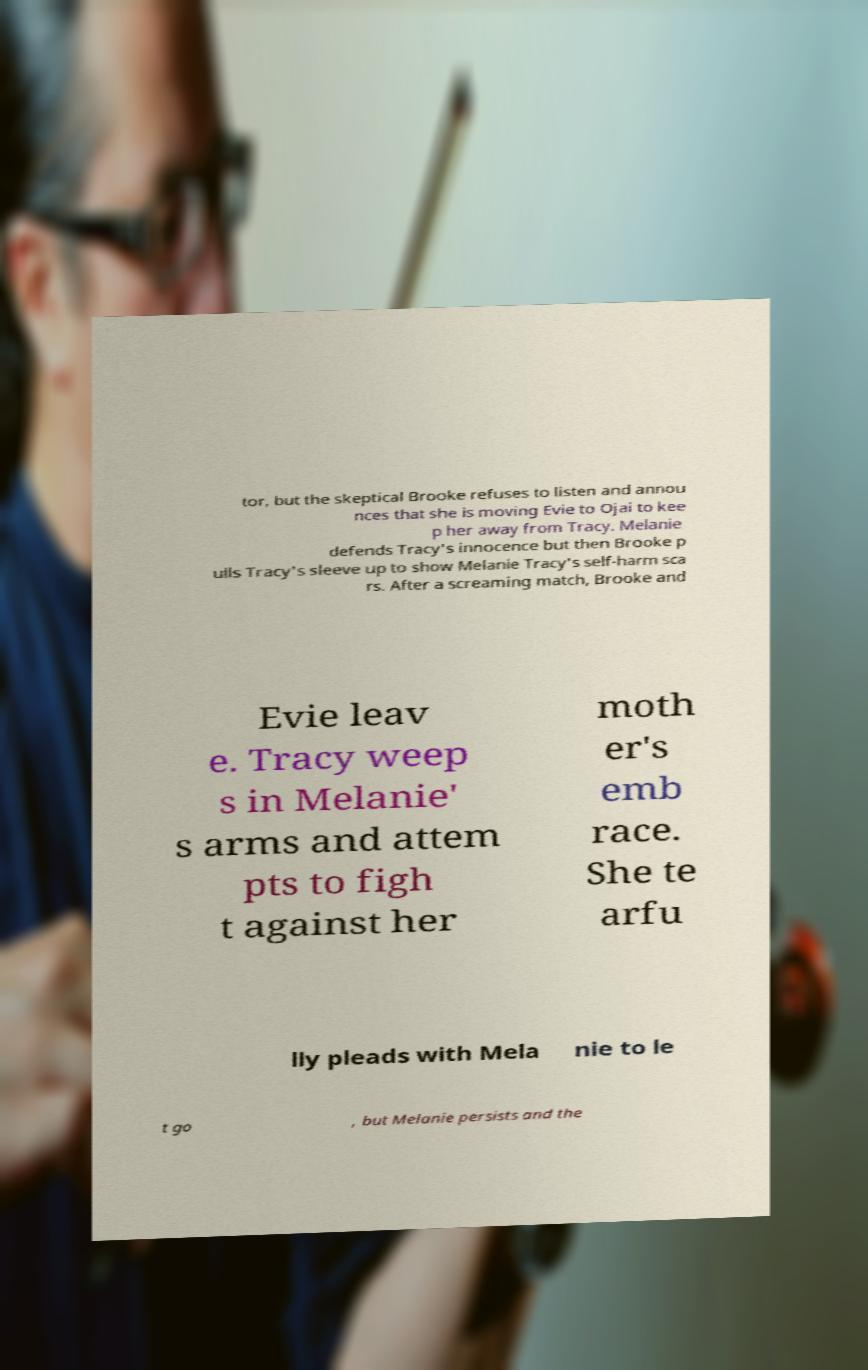For documentation purposes, I need the text within this image transcribed. Could you provide that? tor, but the skeptical Brooke refuses to listen and annou nces that she is moving Evie to Ojai to kee p her away from Tracy. Melanie defends Tracy's innocence but then Brooke p ulls Tracy's sleeve up to show Melanie Tracy's self-harm sca rs. After a screaming match, Brooke and Evie leav e. Tracy weep s in Melanie' s arms and attem pts to figh t against her moth er's emb race. She te arfu lly pleads with Mela nie to le t go , but Melanie persists and the 